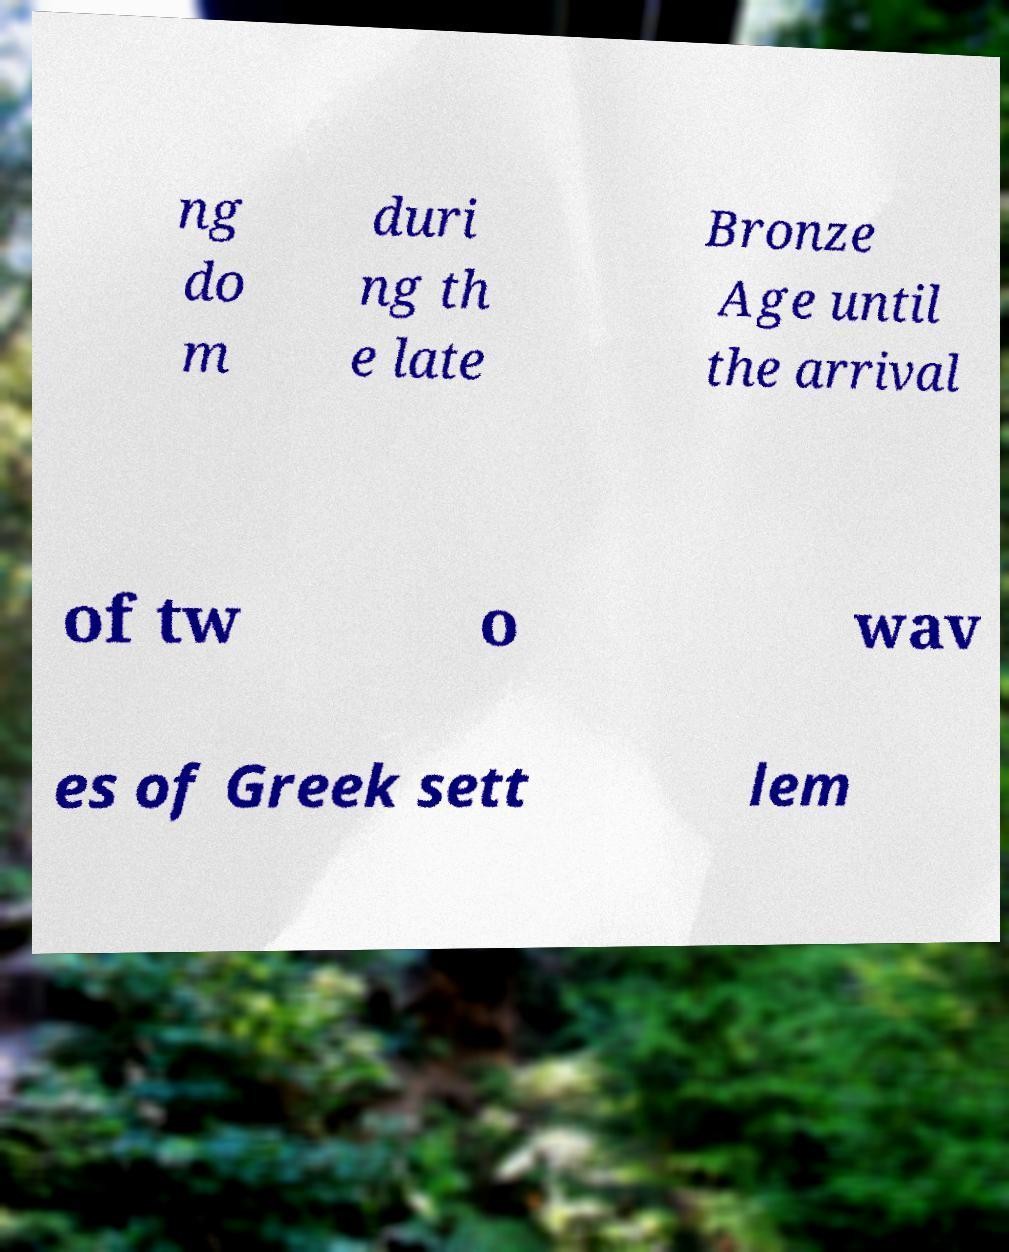Please read and relay the text visible in this image. What does it say? ng do m duri ng th e late Bronze Age until the arrival of tw o wav es of Greek sett lem 